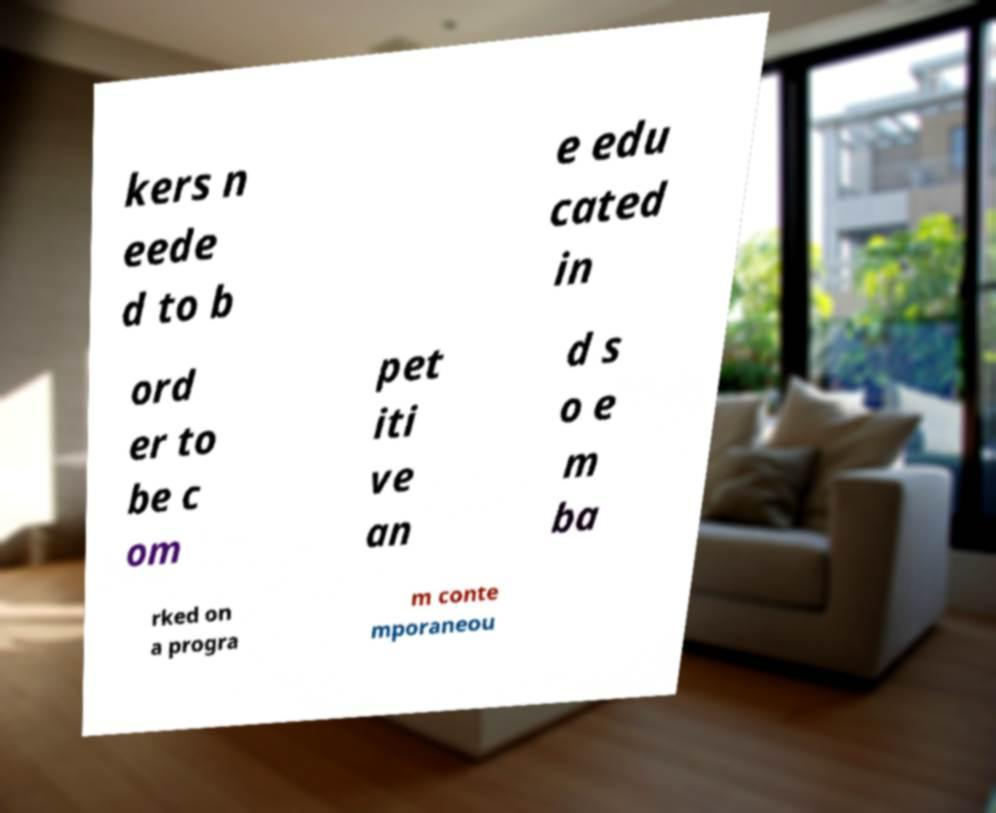Can you read and provide the text displayed in the image?This photo seems to have some interesting text. Can you extract and type it out for me? kers n eede d to b e edu cated in ord er to be c om pet iti ve an d s o e m ba rked on a progra m conte mporaneou 